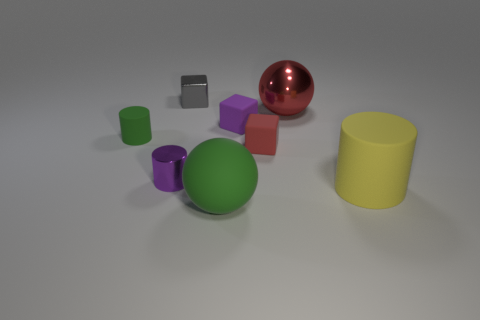Subtract all matte cubes. How many cubes are left? 1 Subtract all red balls. How many balls are left? 1 Subtract 2 balls. How many balls are left? 0 Subtract all blocks. How many objects are left? 5 Subtract all blue balls. Subtract all red cubes. How many balls are left? 2 Subtract all brown spheres. How many green cylinders are left? 1 Subtract all red metal spheres. Subtract all big yellow cylinders. How many objects are left? 6 Add 7 tiny blocks. How many tiny blocks are left? 10 Add 6 small red rubber blocks. How many small red rubber blocks exist? 7 Add 1 small metal cylinders. How many objects exist? 9 